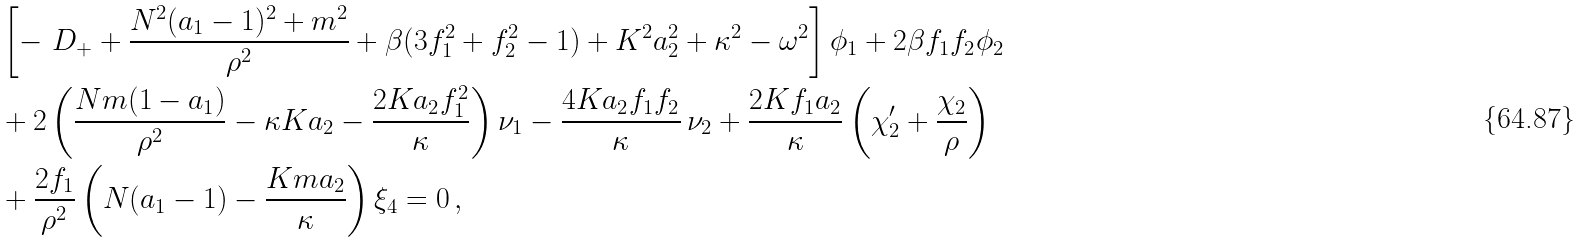<formula> <loc_0><loc_0><loc_500><loc_500>& \left [ - \ D _ { + } + \frac { N ^ { 2 } ( a _ { 1 } - 1 ) ^ { 2 } + m ^ { 2 } } { \rho ^ { 2 } } + \beta ( 3 f _ { 1 } ^ { 2 } + f _ { 2 } ^ { 2 } - 1 ) + K ^ { 2 } a _ { 2 } ^ { 2 } + \kappa ^ { 2 } - \omega ^ { 2 } \right ] \phi _ { 1 } + 2 \beta f _ { 1 } f _ { 2 } \phi _ { 2 } \\ & + 2 \left ( \frac { N m ( 1 - a _ { 1 } ) } { \rho ^ { 2 } } - \kappa K a _ { 2 } - \frac { 2 K a _ { 2 } f _ { 1 } ^ { 2 } } { \kappa } \right ) \nu _ { 1 } - \frac { 4 K a _ { 2 } f _ { 1 } f _ { 2 } } { \kappa } \, \nu _ { 2 } + \frac { 2 K f _ { 1 } a _ { 2 } } { \kappa } \left ( \chi _ { 2 } ^ { \prime } + \frac { \chi _ { 2 } } { \rho } \right ) \\ & + \frac { 2 f _ { 1 } } { \rho ^ { 2 } } \left ( N ( a _ { 1 } - 1 ) - \frac { K m a _ { 2 } } { \kappa } \right ) \xi _ { 4 } = 0 \, ,</formula> 